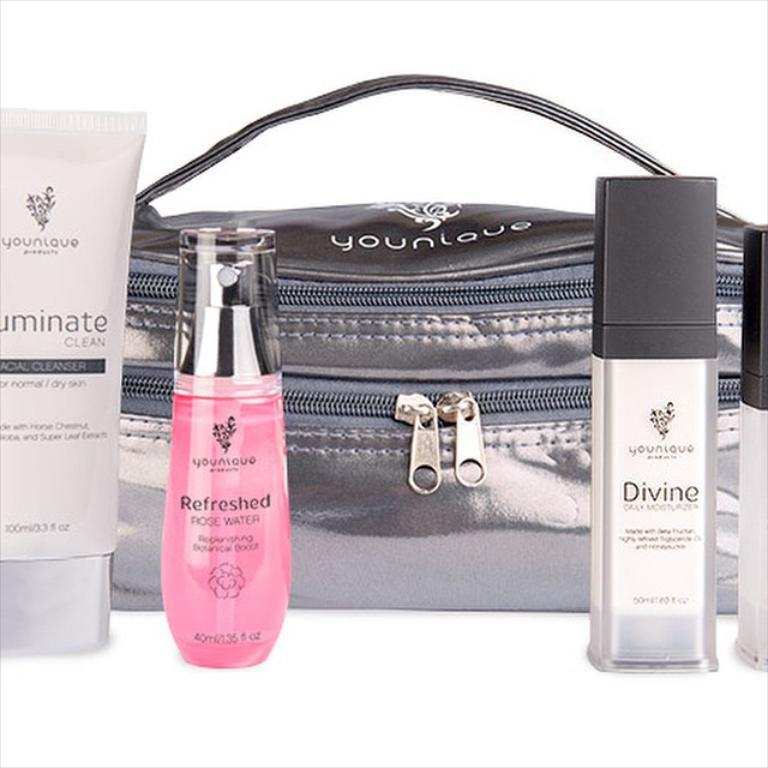Is this a fragnance?
Your response must be concise. Yes. 